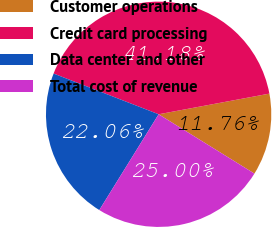Convert chart. <chart><loc_0><loc_0><loc_500><loc_500><pie_chart><fcel>Customer operations<fcel>Credit card processing<fcel>Data center and other<fcel>Total cost of revenue<nl><fcel>11.76%<fcel>41.18%<fcel>22.06%<fcel>25.0%<nl></chart> 